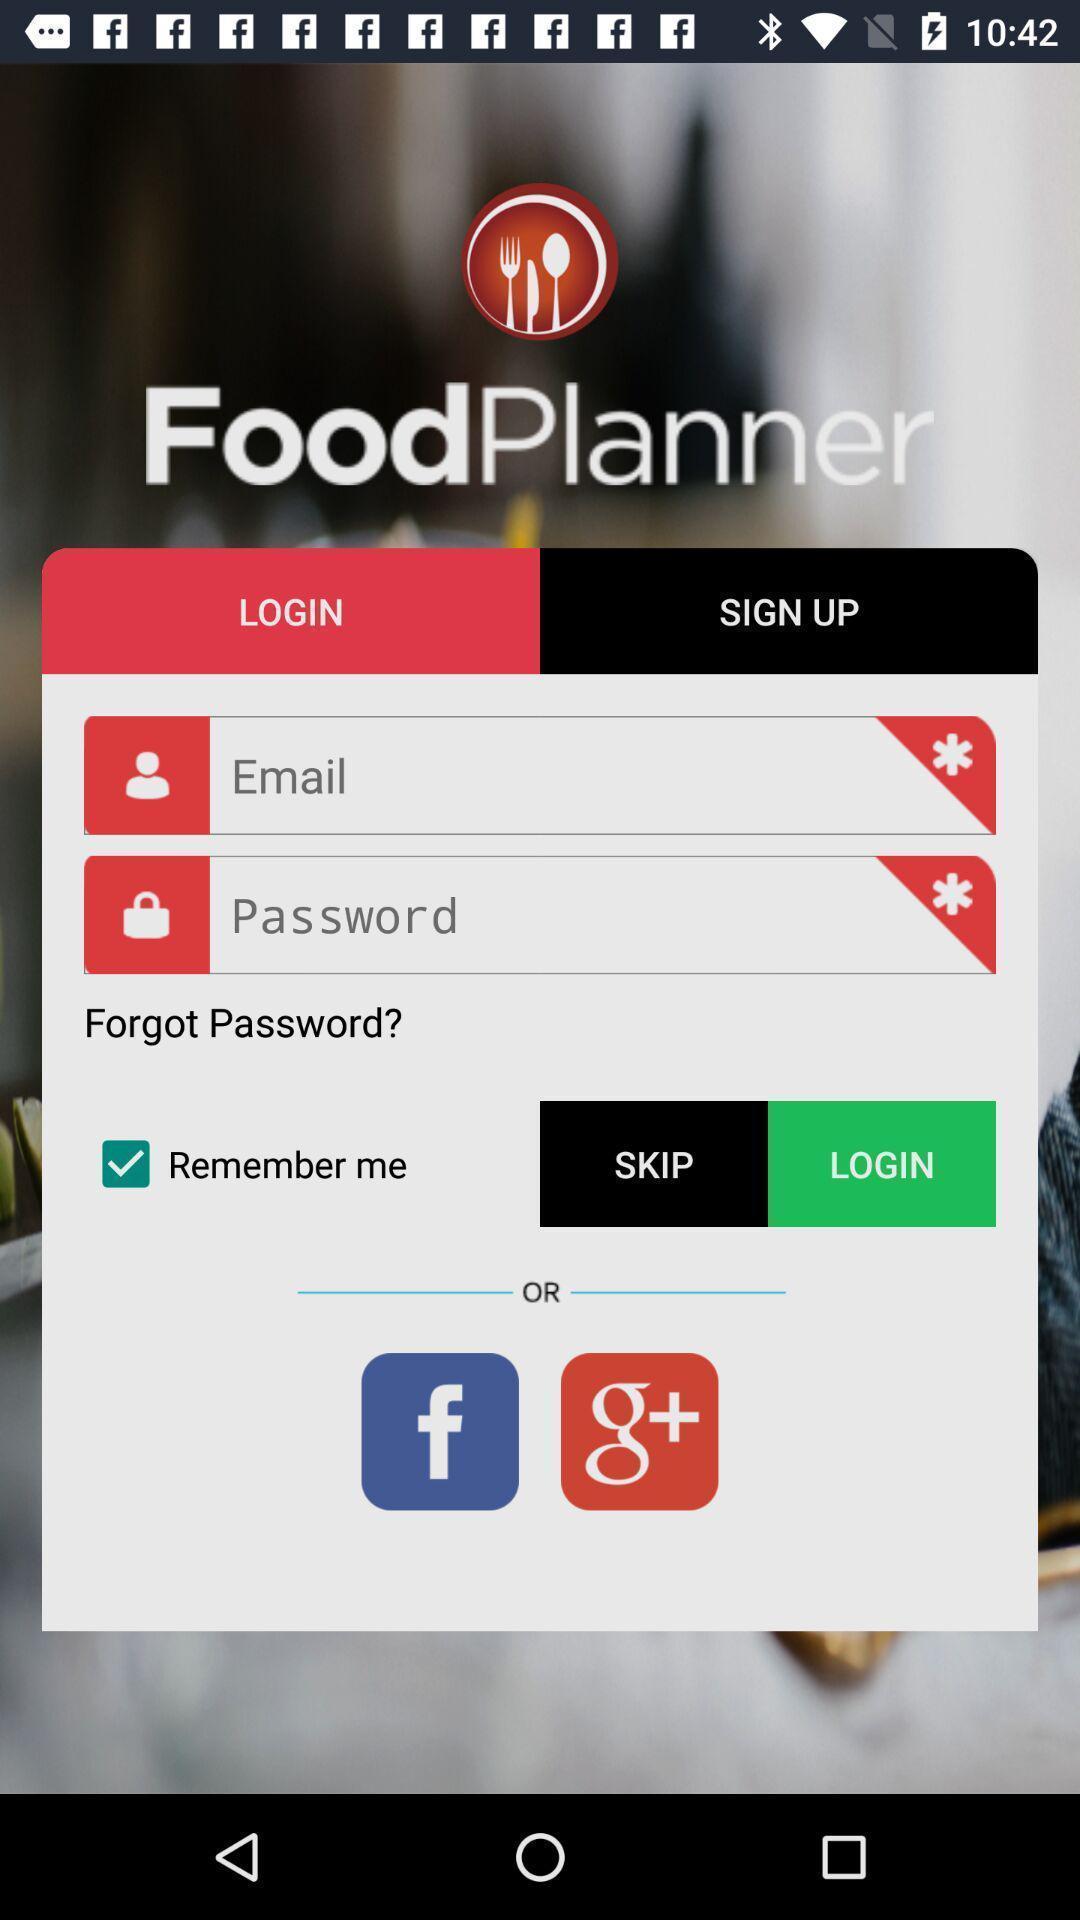Provide a description of this screenshot. Welcome page showing of login option. 